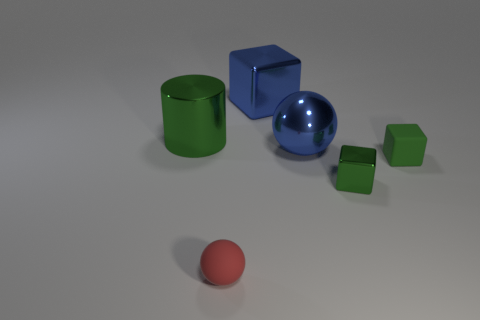Subtract all blue balls. How many green cubes are left? 2 Add 2 big blue metallic balls. How many objects exist? 8 Subtract all spheres. How many objects are left? 4 Add 5 matte blocks. How many matte blocks exist? 6 Subtract 0 cyan cylinders. How many objects are left? 6 Subtract all blue shiny balls. Subtract all small green cubes. How many objects are left? 3 Add 3 large blue balls. How many large blue balls are left? 4 